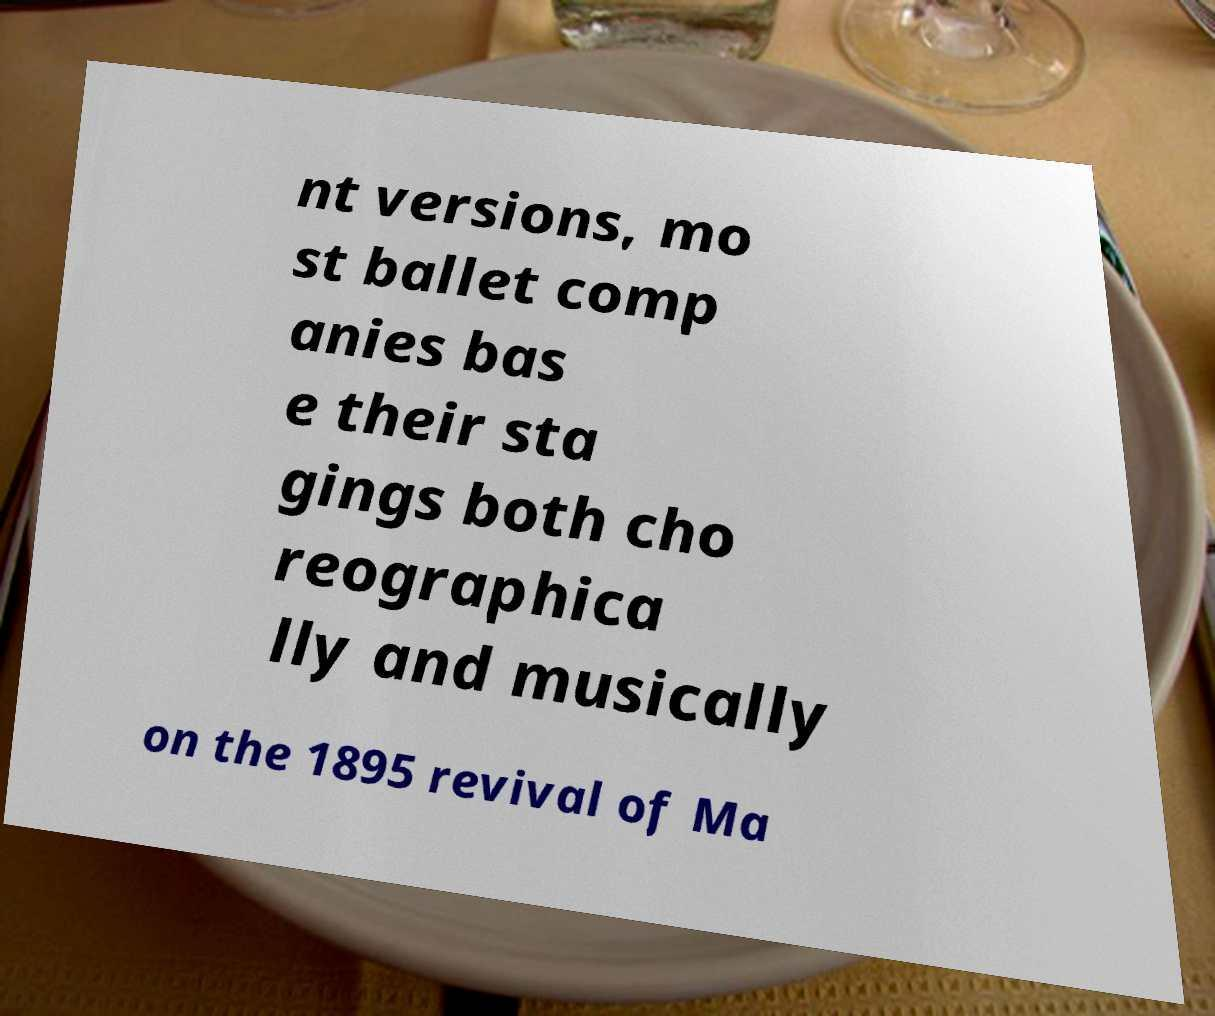Could you assist in decoding the text presented in this image and type it out clearly? nt versions, mo st ballet comp anies bas e their sta gings both cho reographica lly and musically on the 1895 revival of Ma 